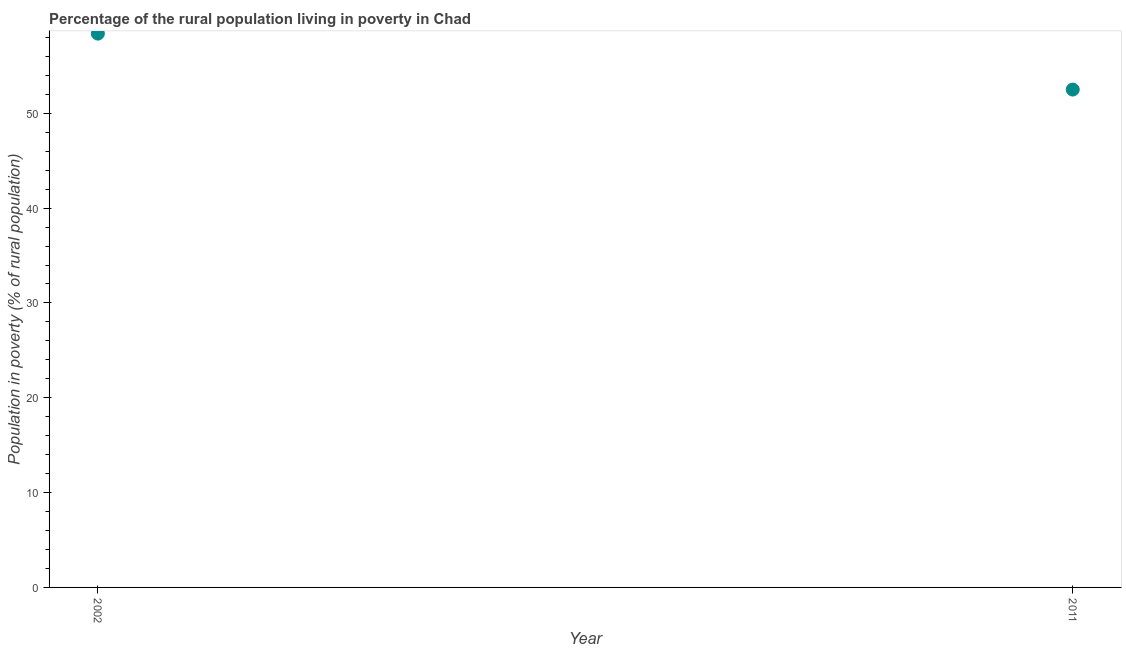What is the percentage of rural population living below poverty line in 2011?
Provide a succinct answer. 52.5. Across all years, what is the maximum percentage of rural population living below poverty line?
Keep it short and to the point. 58.4. Across all years, what is the minimum percentage of rural population living below poverty line?
Provide a short and direct response. 52.5. In which year was the percentage of rural population living below poverty line maximum?
Provide a succinct answer. 2002. What is the sum of the percentage of rural population living below poverty line?
Offer a very short reply. 110.9. What is the difference between the percentage of rural population living below poverty line in 2002 and 2011?
Make the answer very short. 5.9. What is the average percentage of rural population living below poverty line per year?
Your answer should be very brief. 55.45. What is the median percentage of rural population living below poverty line?
Give a very brief answer. 55.45. In how many years, is the percentage of rural population living below poverty line greater than 42 %?
Make the answer very short. 2. Do a majority of the years between 2011 and 2002 (inclusive) have percentage of rural population living below poverty line greater than 20 %?
Give a very brief answer. No. What is the ratio of the percentage of rural population living below poverty line in 2002 to that in 2011?
Offer a terse response. 1.11. In how many years, is the percentage of rural population living below poverty line greater than the average percentage of rural population living below poverty line taken over all years?
Keep it short and to the point. 1. Does the percentage of rural population living below poverty line monotonically increase over the years?
Provide a succinct answer. No. How many dotlines are there?
Your response must be concise. 1. What is the difference between two consecutive major ticks on the Y-axis?
Make the answer very short. 10. Are the values on the major ticks of Y-axis written in scientific E-notation?
Your answer should be compact. No. Does the graph contain grids?
Your answer should be very brief. No. What is the title of the graph?
Keep it short and to the point. Percentage of the rural population living in poverty in Chad. What is the label or title of the Y-axis?
Give a very brief answer. Population in poverty (% of rural population). What is the Population in poverty (% of rural population) in 2002?
Give a very brief answer. 58.4. What is the Population in poverty (% of rural population) in 2011?
Provide a short and direct response. 52.5. What is the difference between the Population in poverty (% of rural population) in 2002 and 2011?
Offer a very short reply. 5.9. What is the ratio of the Population in poverty (% of rural population) in 2002 to that in 2011?
Provide a succinct answer. 1.11. 